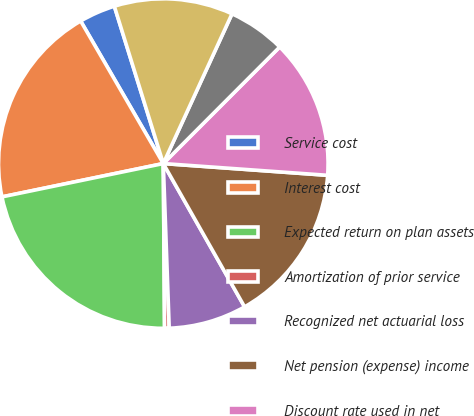Convert chart to OTSL. <chart><loc_0><loc_0><loc_500><loc_500><pie_chart><fcel>Service cost<fcel>Interest cost<fcel>Expected return on plan assets<fcel>Amortization of prior service<fcel>Recognized net actuarial loss<fcel>Net pension (expense) income<fcel>Discount rate used in net<fcel>Rate of compensation increase<fcel>Discount rate used in benefit<nl><fcel>3.56%<fcel>19.88%<fcel>21.88%<fcel>0.45%<fcel>7.64%<fcel>15.65%<fcel>13.65%<fcel>5.64%<fcel>11.65%<nl></chart> 